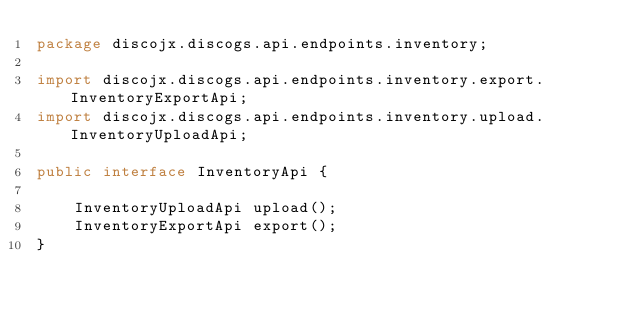Convert code to text. <code><loc_0><loc_0><loc_500><loc_500><_Java_>package discojx.discogs.api.endpoints.inventory;

import discojx.discogs.api.endpoints.inventory.export.InventoryExportApi;
import discojx.discogs.api.endpoints.inventory.upload.InventoryUploadApi;

public interface InventoryApi {

    InventoryUploadApi upload();
    InventoryExportApi export();
}
</code> 